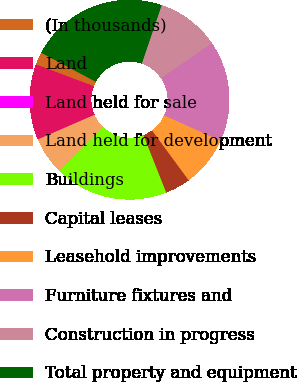Convert chart to OTSL. <chart><loc_0><loc_0><loc_500><loc_500><pie_chart><fcel>(In thousands)<fcel>Land<fcel>Land held for sale<fcel>Land held for development<fcel>Buildings<fcel>Capital leases<fcel>Leasehold improvements<fcel>Furniture fixtures and<fcel>Construction in progress<fcel>Total property and equipment<nl><fcel>2.06%<fcel>12.24%<fcel>0.02%<fcel>6.13%<fcel>18.35%<fcel>4.09%<fcel>8.17%<fcel>16.32%<fcel>10.2%<fcel>22.43%<nl></chart> 